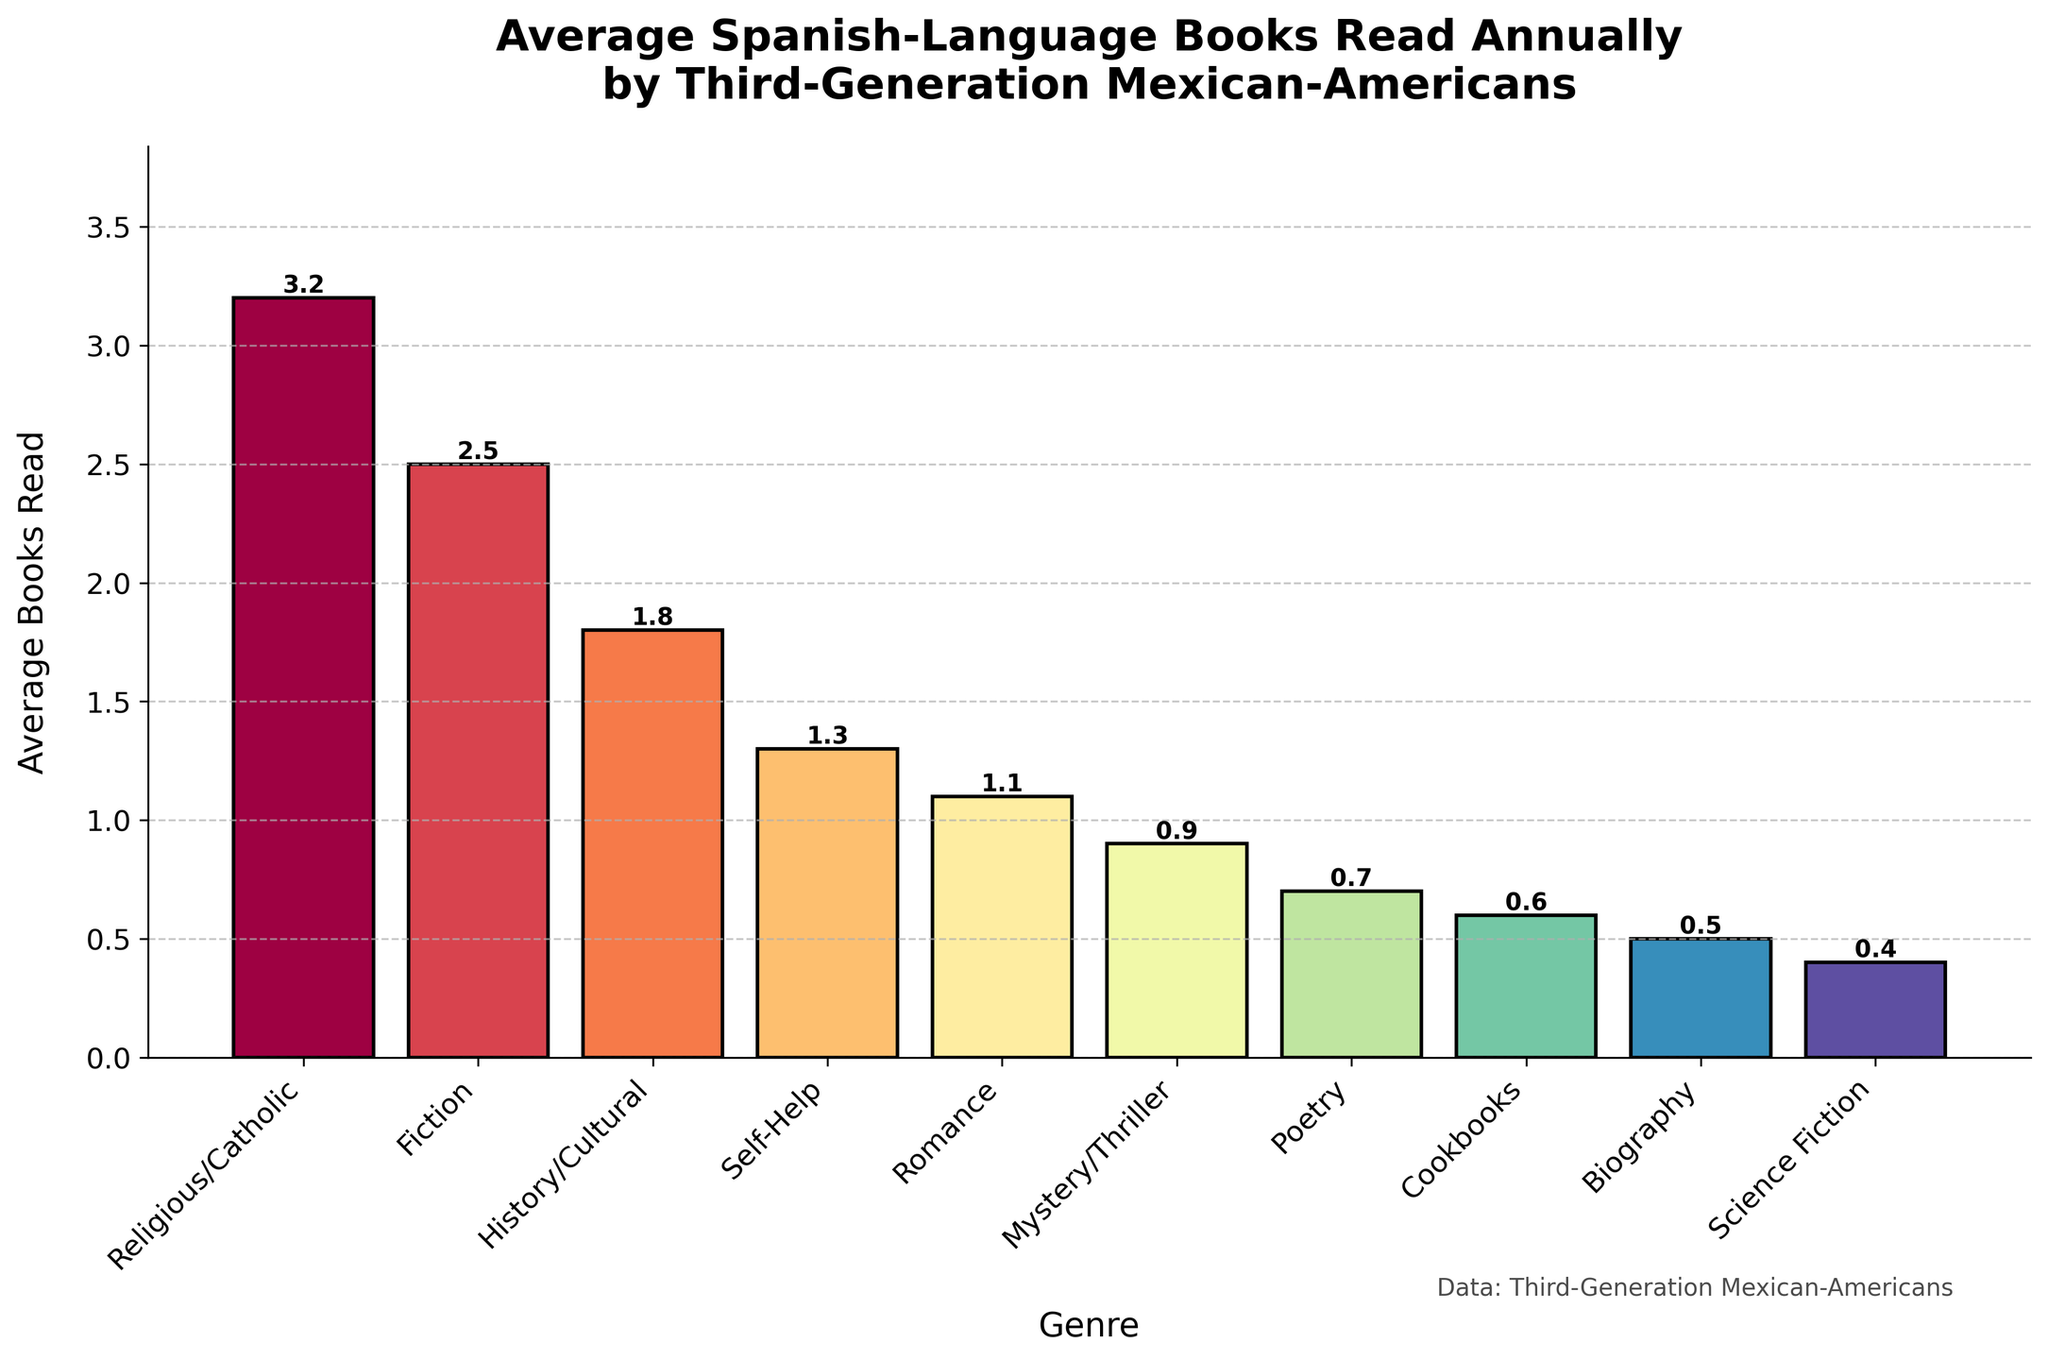What's the genre with the highest average number of Spanish-language books read annually? The figure shows the average number of Spanish-language books read annually by genre. The highest bar represents the Religious/Catholic genre with an average of 3.2 books read annually.
Answer: Religious/Catholic Which genre shows the lowest average number of Spanish-language books read annually? The figure shows the average number of Spanish-language books read annually by genre. The lowest bar represents Science Fiction with an average of 0.4 books read annually.
Answer: Science Fiction How many genres have an average of at least 1 Spanish-language book read annually? From the figure, count the genres with bars reaching or exceeding the 1 mark on the y-axis. These genres are Religious/Catholic, Fiction, History/Cultural, Self-Help, and Romance.
Answer: 5 What is the combined average number of Spanish-language books read annually for Mystery/Thriller and Poetry genres? According to the figure, the average number of Spanish-language books read annually for Mystery/Thriller is 0.9 and for Poetry is 0.7. Adding these two together, 0.9 + 0.7 = 1.6.
Answer: 1.6 How does the average number of Spanish-language books read in the Fiction genre compare to the History/Cultural genre? The bar for Fiction shows an average of 2.5 books read annually while History/Cultural shows 1.8 books. 2.5 is greater than 1.8.
Answer: Fiction has a higher average Which group reads more Spanish-language books annually: Self-Help or Biography? The figure shows that Self-Help has an average of 1.3 books read annually while Biography has 0.5. 1.3 is greater than 0.5.
Answer: Self-Help What's the difference in average books read between the Religious/Catholic and Cookbooks genres? The figure indicates that the average for Religious/Catholic is 3.2, and for Cookbooks, it is 0.6. The difference is 3.2 - 0.6 = 2.6.
Answer: 2.6 Which genres have fewer than 1 Spanish-language book read annually on average, and how many are there? By observing the bars that fall below the 1 mark on the y-axis, the genres are Mystery/Thriller, Poetry, Cookbooks, Biography, and Science Fiction. Counting these, there are 5 such genres.
Answer: 5 Identify two genres that have approximately the same average of Spanish-language books read annually. From the figure, Fiction (2.5) and History/Cultural (1.8) don't match exactly, but are not very far off. More closely matched are Romance (1.1) and Mystery/Thriller (0.9).
Answer: Romance and Mystery/Thriller 